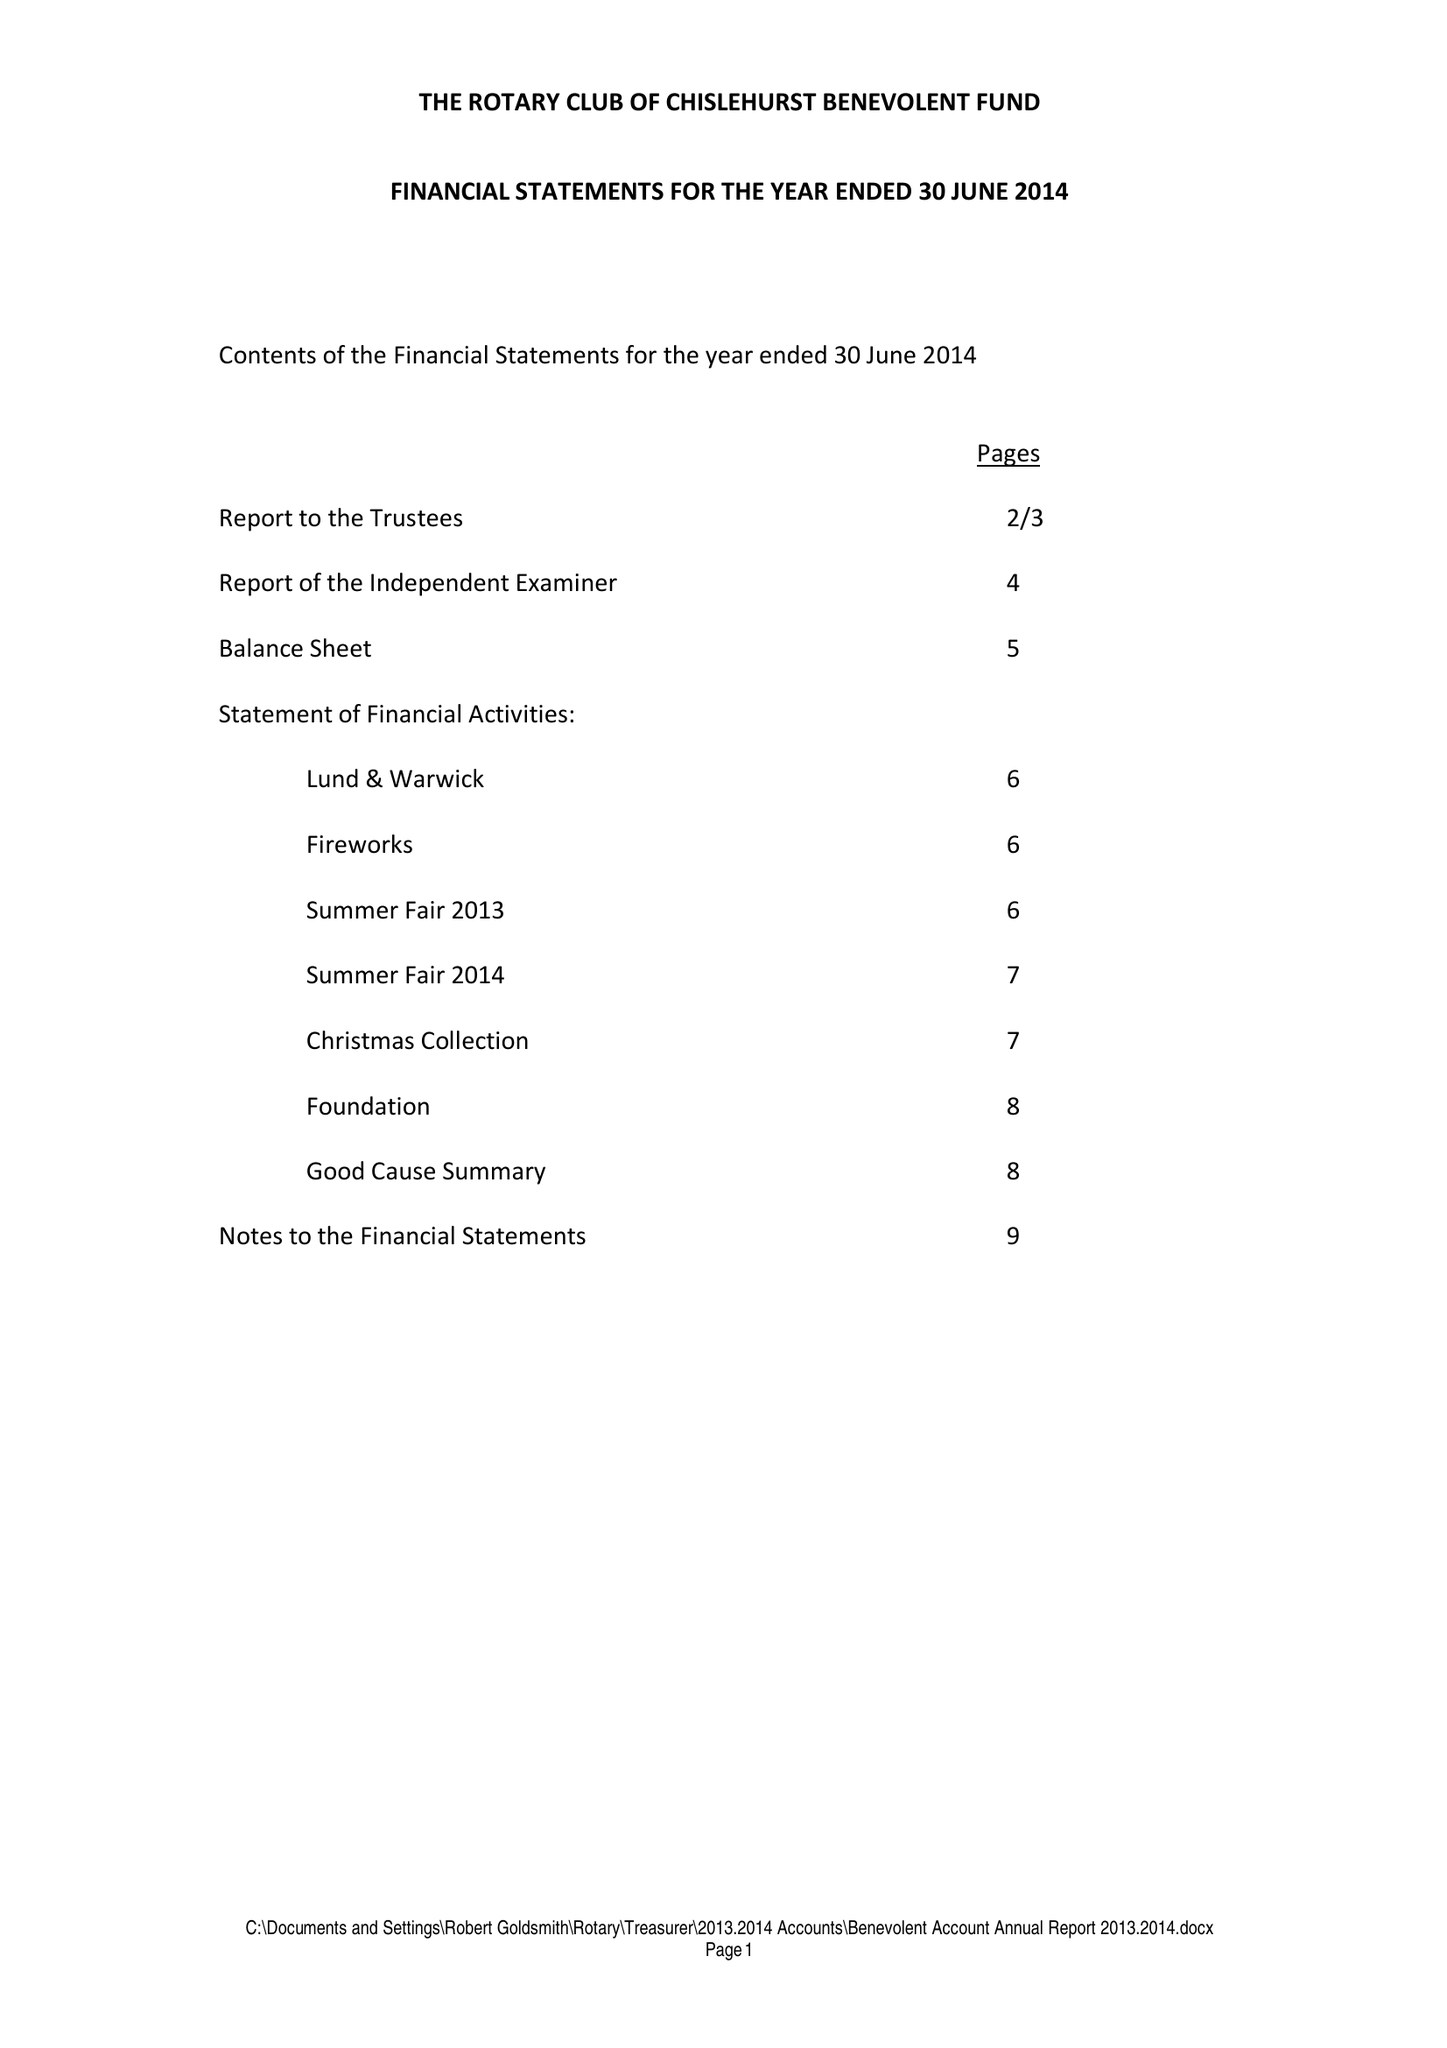What is the value for the spending_annually_in_british_pounds?
Answer the question using a single word or phrase. 31422.00 